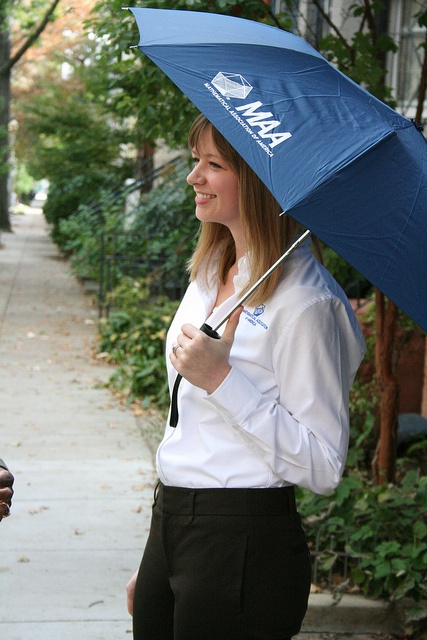Describe the objects in this image and their specific colors. I can see people in darkgreen, black, lightgray, darkgray, and gray tones and umbrella in darkgreen, navy, gray, blue, and lightblue tones in this image. 